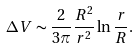<formula> <loc_0><loc_0><loc_500><loc_500>\Delta V \sim \frac { 2 } { 3 \pi } \frac { R ^ { 2 } } { r ^ { 2 } } \ln \frac { r } { R } .</formula> 